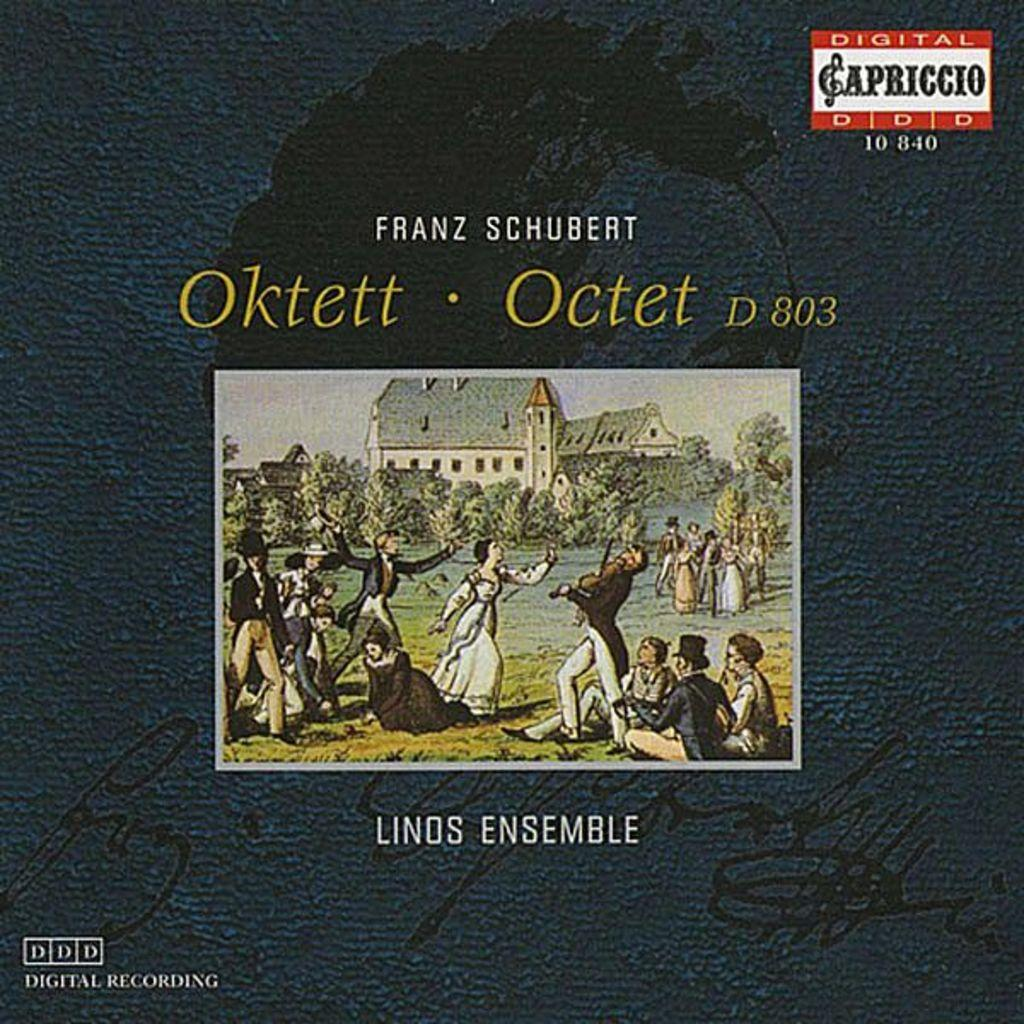<image>
Give a short and clear explanation of the subsequent image. ALbum cover showing people near a building and the words LINOS ENSEMBLE on the bottom. 